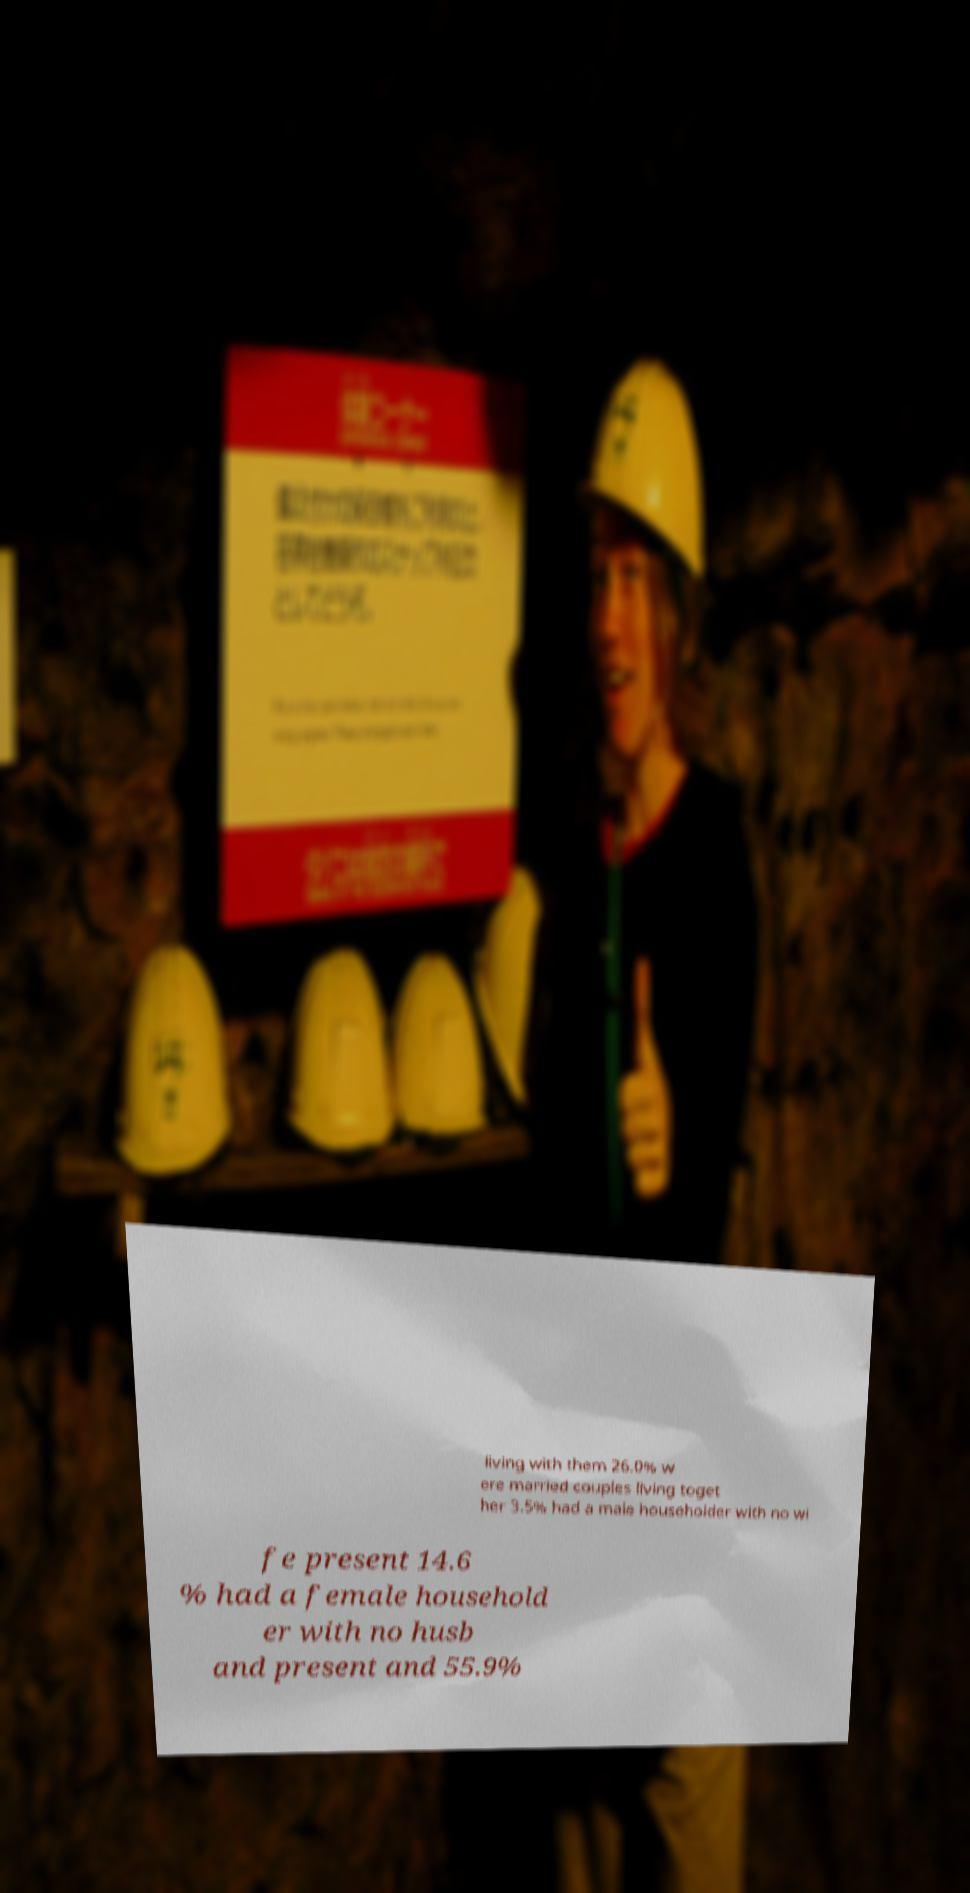Please identify and transcribe the text found in this image. living with them 26.0% w ere married couples living toget her 3.5% had a male householder with no wi fe present 14.6 % had a female household er with no husb and present and 55.9% 